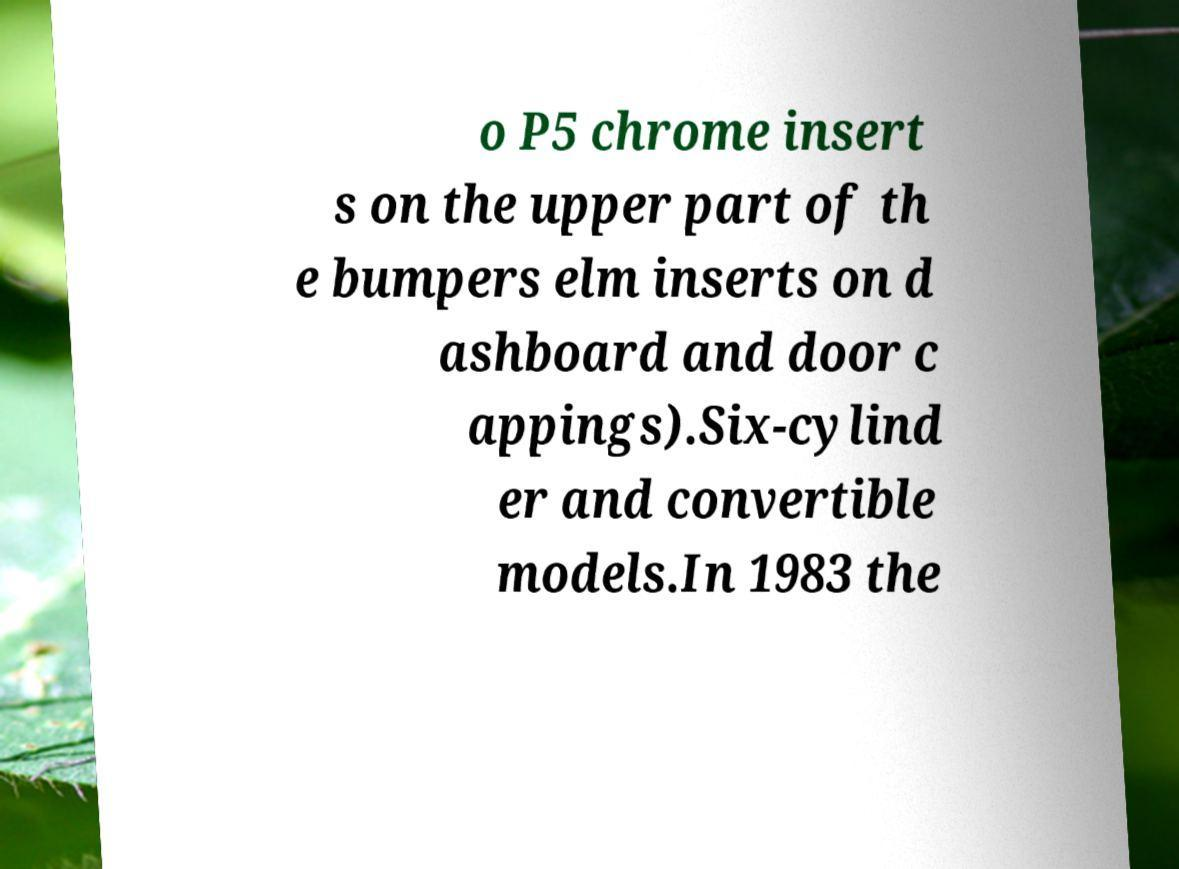I need the written content from this picture converted into text. Can you do that? o P5 chrome insert s on the upper part of th e bumpers elm inserts on d ashboard and door c appings).Six-cylind er and convertible models.In 1983 the 